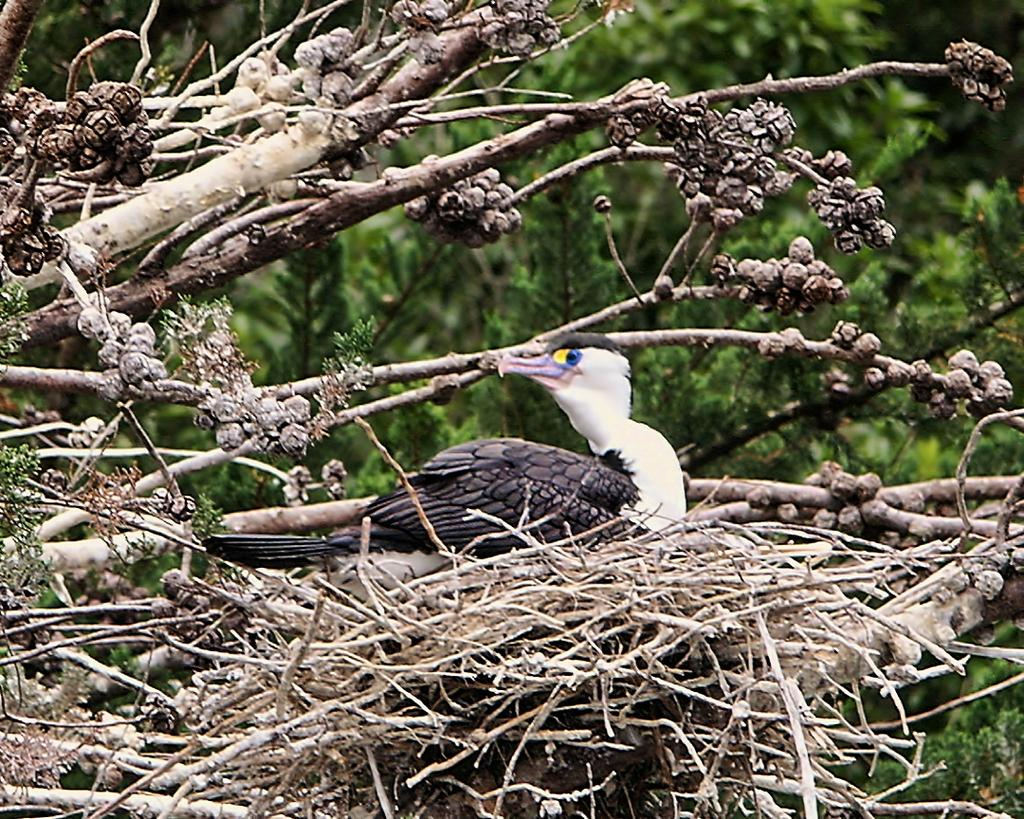What is located on the tree in the image? There is a nest on a tree in the image. What can be seen inside the nest? There is there a bird on the nest? What type of vegetation is visible in the background of the image? There are trees visible in the background of the image. How many drawers are visible in the image? There are no drawers present in the image. What type of change is the bird making in the image? There is no indication of any change being made by the bird in the image. 